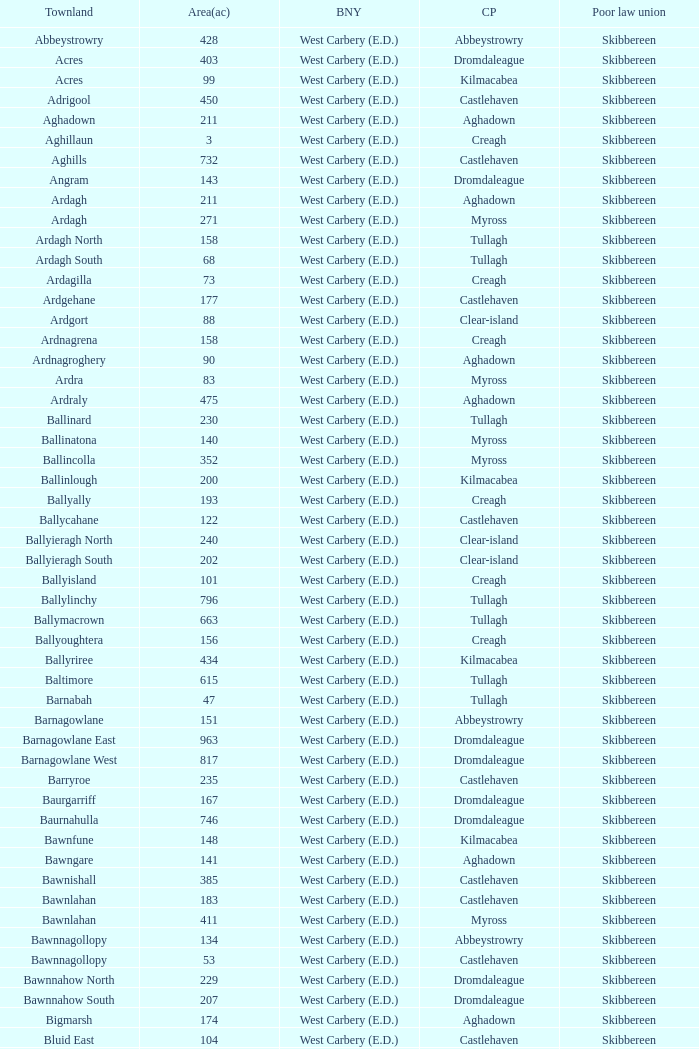What are the Baronies when the area (in acres) is 276? West Carbery (E.D.). 